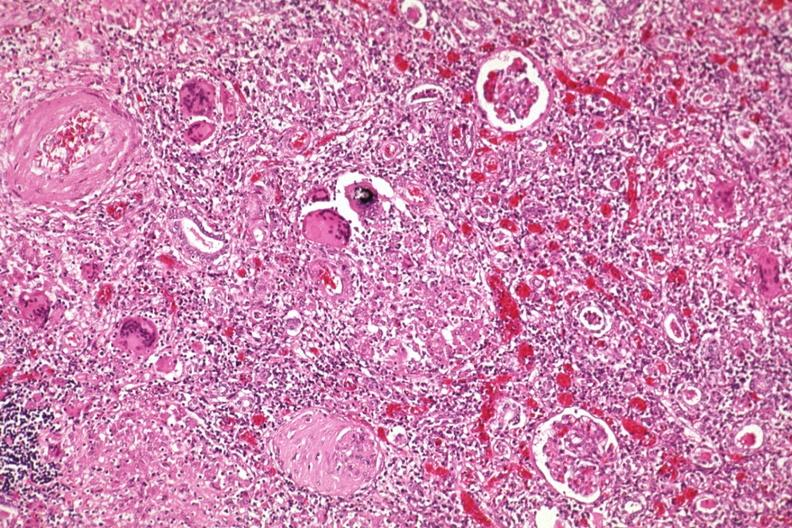does this image show giant cells?
Answer the question using a single word or phrase. Yes 